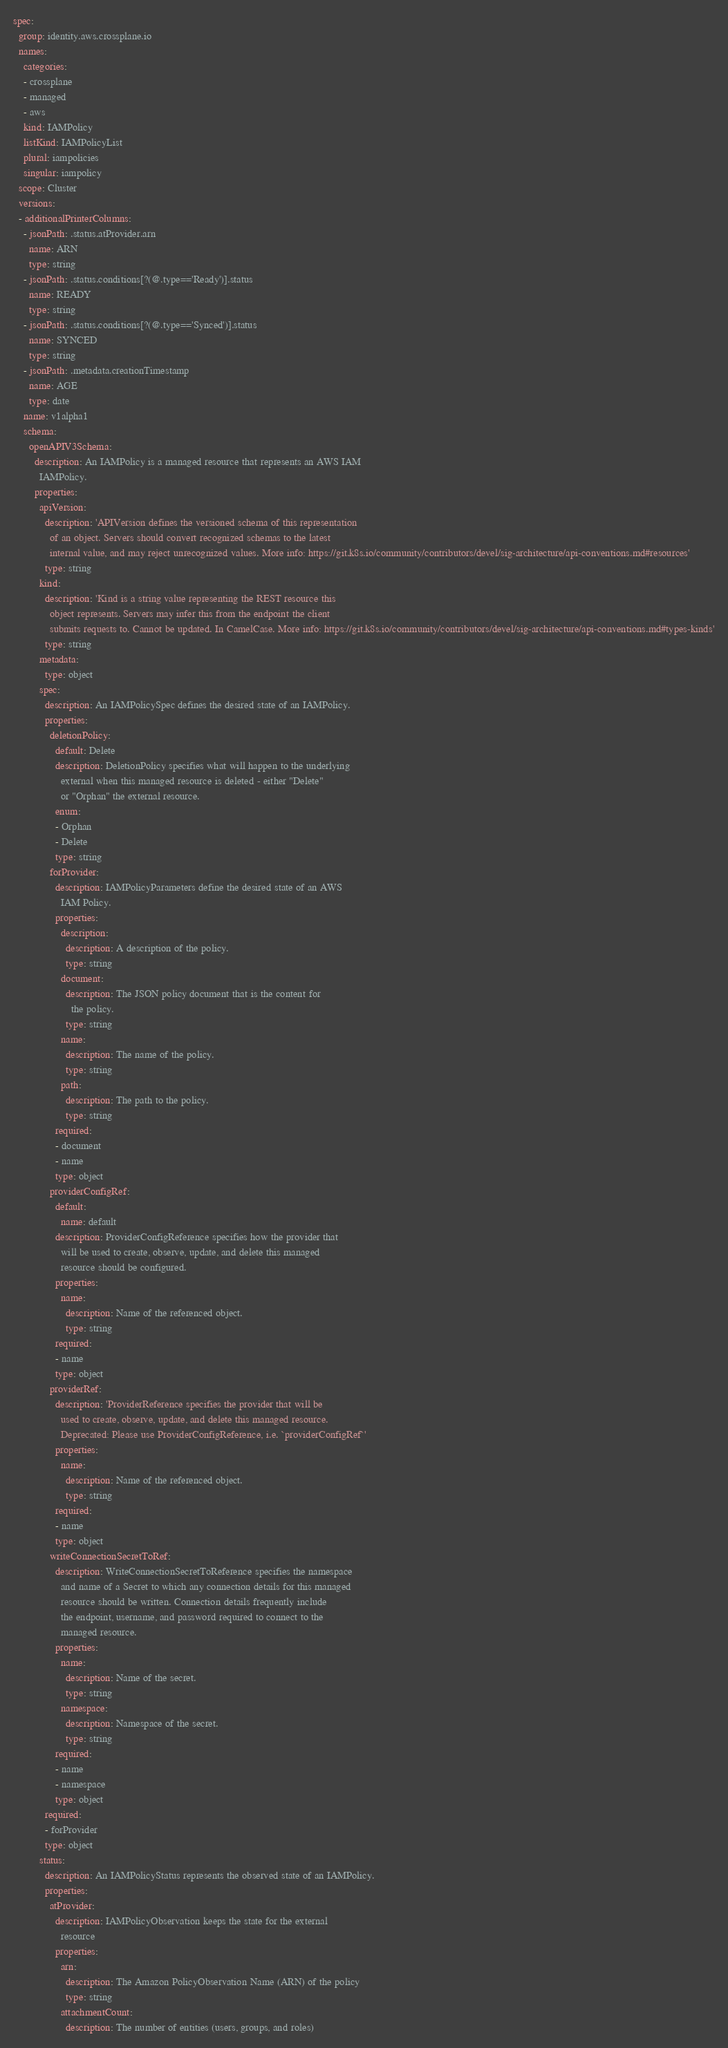Convert code to text. <code><loc_0><loc_0><loc_500><loc_500><_YAML_>spec:
  group: identity.aws.crossplane.io
  names:
    categories:
    - crossplane
    - managed
    - aws
    kind: IAMPolicy
    listKind: IAMPolicyList
    plural: iampolicies
    singular: iampolicy
  scope: Cluster
  versions:
  - additionalPrinterColumns:
    - jsonPath: .status.atProvider.arn
      name: ARN
      type: string
    - jsonPath: .status.conditions[?(@.type=='Ready')].status
      name: READY
      type: string
    - jsonPath: .status.conditions[?(@.type=='Synced')].status
      name: SYNCED
      type: string
    - jsonPath: .metadata.creationTimestamp
      name: AGE
      type: date
    name: v1alpha1
    schema:
      openAPIV3Schema:
        description: An IAMPolicy is a managed resource that represents an AWS IAM
          IAMPolicy.
        properties:
          apiVersion:
            description: 'APIVersion defines the versioned schema of this representation
              of an object. Servers should convert recognized schemas to the latest
              internal value, and may reject unrecognized values. More info: https://git.k8s.io/community/contributors/devel/sig-architecture/api-conventions.md#resources'
            type: string
          kind:
            description: 'Kind is a string value representing the REST resource this
              object represents. Servers may infer this from the endpoint the client
              submits requests to. Cannot be updated. In CamelCase. More info: https://git.k8s.io/community/contributors/devel/sig-architecture/api-conventions.md#types-kinds'
            type: string
          metadata:
            type: object
          spec:
            description: An IAMPolicySpec defines the desired state of an IAMPolicy.
            properties:
              deletionPolicy:
                default: Delete
                description: DeletionPolicy specifies what will happen to the underlying
                  external when this managed resource is deleted - either "Delete"
                  or "Orphan" the external resource.
                enum:
                - Orphan
                - Delete
                type: string
              forProvider:
                description: IAMPolicyParameters define the desired state of an AWS
                  IAM Policy.
                properties:
                  description:
                    description: A description of the policy.
                    type: string
                  document:
                    description: The JSON policy document that is the content for
                      the policy.
                    type: string
                  name:
                    description: The name of the policy.
                    type: string
                  path:
                    description: The path to the policy.
                    type: string
                required:
                - document
                - name
                type: object
              providerConfigRef:
                default:
                  name: default
                description: ProviderConfigReference specifies how the provider that
                  will be used to create, observe, update, and delete this managed
                  resource should be configured.
                properties:
                  name:
                    description: Name of the referenced object.
                    type: string
                required:
                - name
                type: object
              providerRef:
                description: 'ProviderReference specifies the provider that will be
                  used to create, observe, update, and delete this managed resource.
                  Deprecated: Please use ProviderConfigReference, i.e. `providerConfigRef`'
                properties:
                  name:
                    description: Name of the referenced object.
                    type: string
                required:
                - name
                type: object
              writeConnectionSecretToRef:
                description: WriteConnectionSecretToReference specifies the namespace
                  and name of a Secret to which any connection details for this managed
                  resource should be written. Connection details frequently include
                  the endpoint, username, and password required to connect to the
                  managed resource.
                properties:
                  name:
                    description: Name of the secret.
                    type: string
                  namespace:
                    description: Namespace of the secret.
                    type: string
                required:
                - name
                - namespace
                type: object
            required:
            - forProvider
            type: object
          status:
            description: An IAMPolicyStatus represents the observed state of an IAMPolicy.
            properties:
              atProvider:
                description: IAMPolicyObservation keeps the state for the external
                  resource
                properties:
                  arn:
                    description: The Amazon PolicyObservation Name (ARN) of the policy
                    type: string
                  attachmentCount:
                    description: The number of entities (users, groups, and roles)</code> 